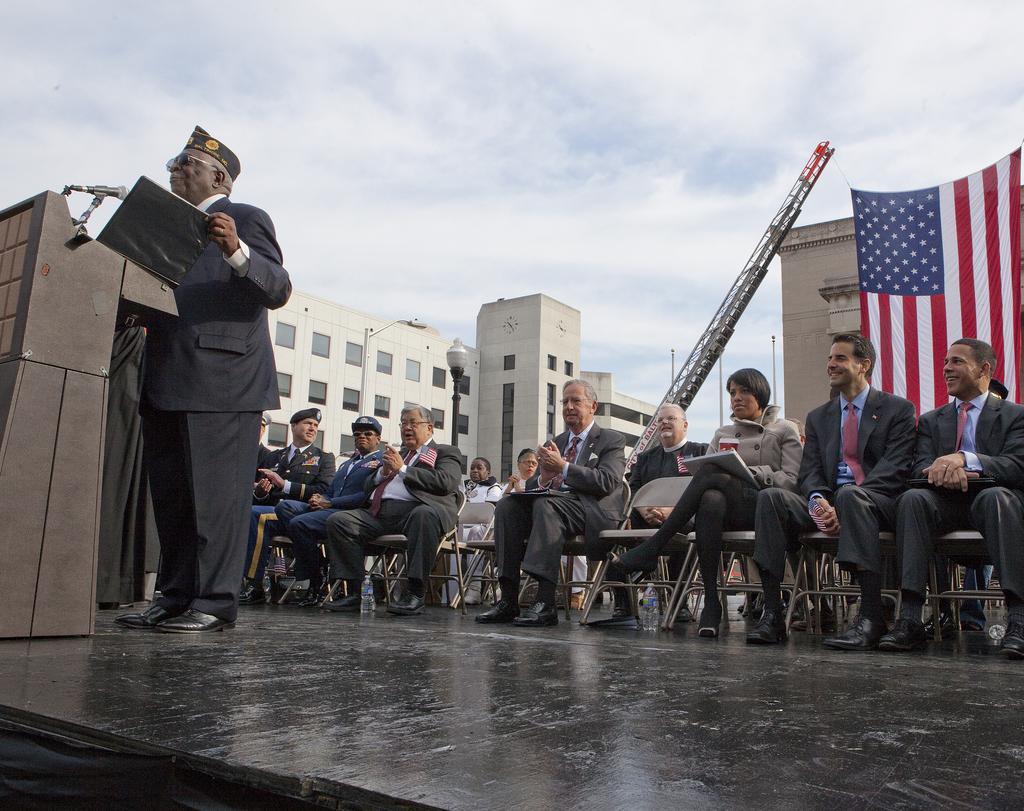In one or two sentences, can you explain what this image depicts? In this image I can see a person standing wearing black dress, in front of the person I can see a podium and a microphone. Background I can see few other persons sitting on chairs, flag in red, blue and white color, building in white color and sky in white color. 